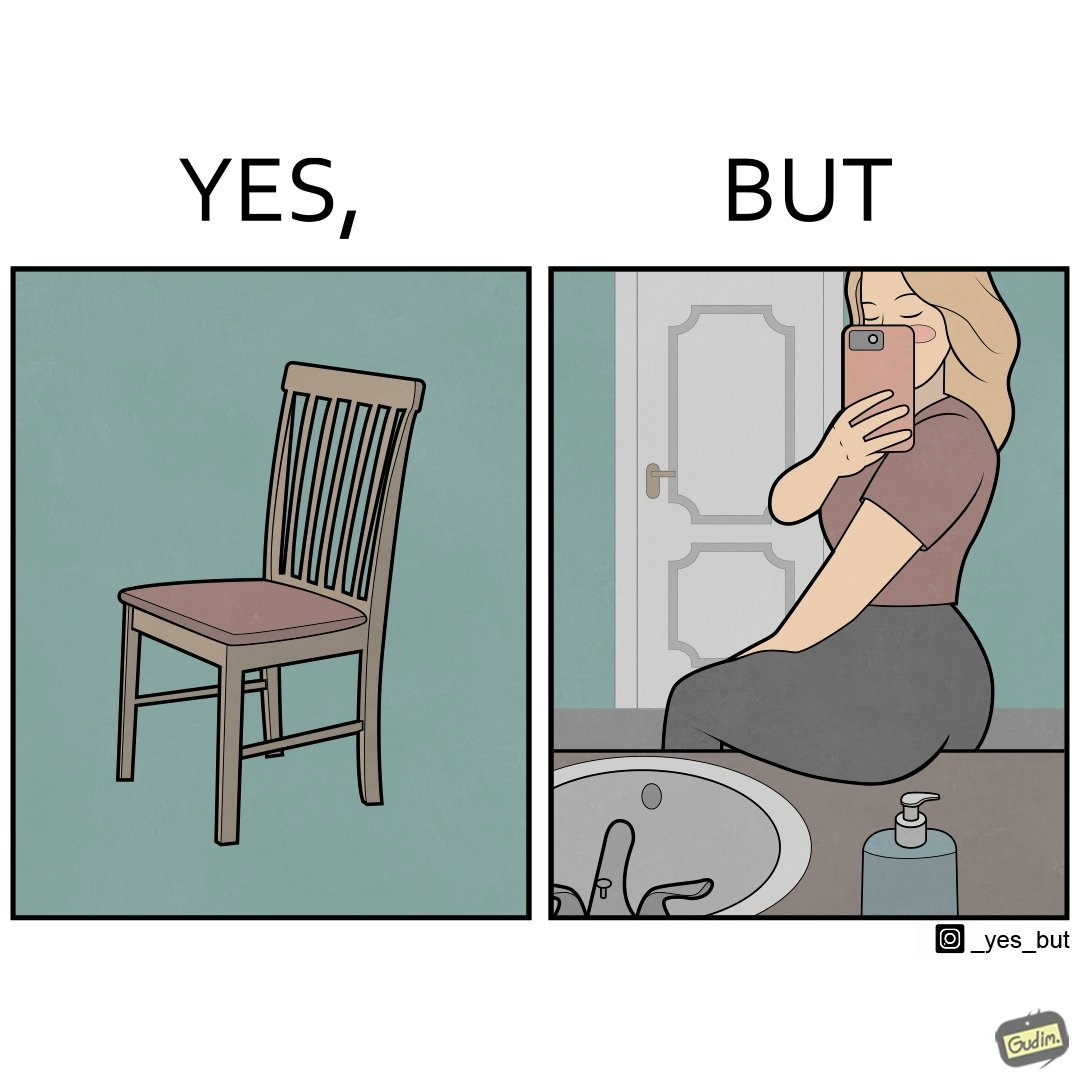What is shown in this image? The image is ironical, as a woman is sitting by the sink taking a selfie using a mirror, while not using a chair that is actually meant for sitting. 